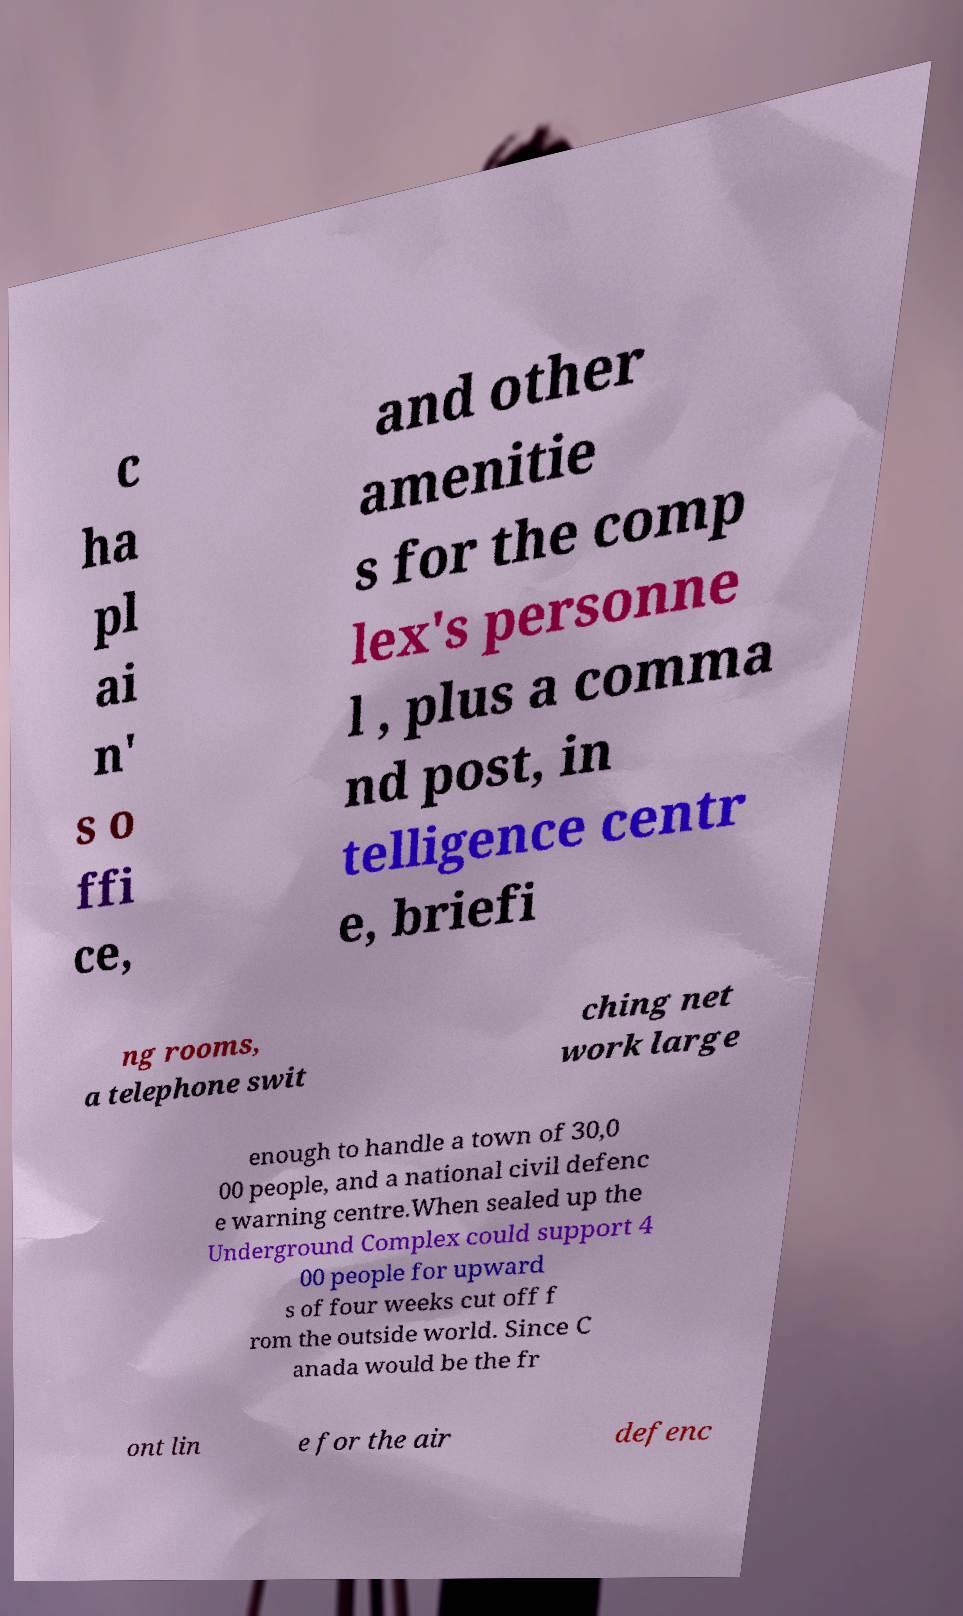Can you read and provide the text displayed in the image?This photo seems to have some interesting text. Can you extract and type it out for me? c ha pl ai n' s o ffi ce, and other amenitie s for the comp lex's personne l , plus a comma nd post, in telligence centr e, briefi ng rooms, a telephone swit ching net work large enough to handle a town of 30,0 00 people, and a national civil defenc e warning centre.When sealed up the Underground Complex could support 4 00 people for upward s of four weeks cut off f rom the outside world. Since C anada would be the fr ont lin e for the air defenc 